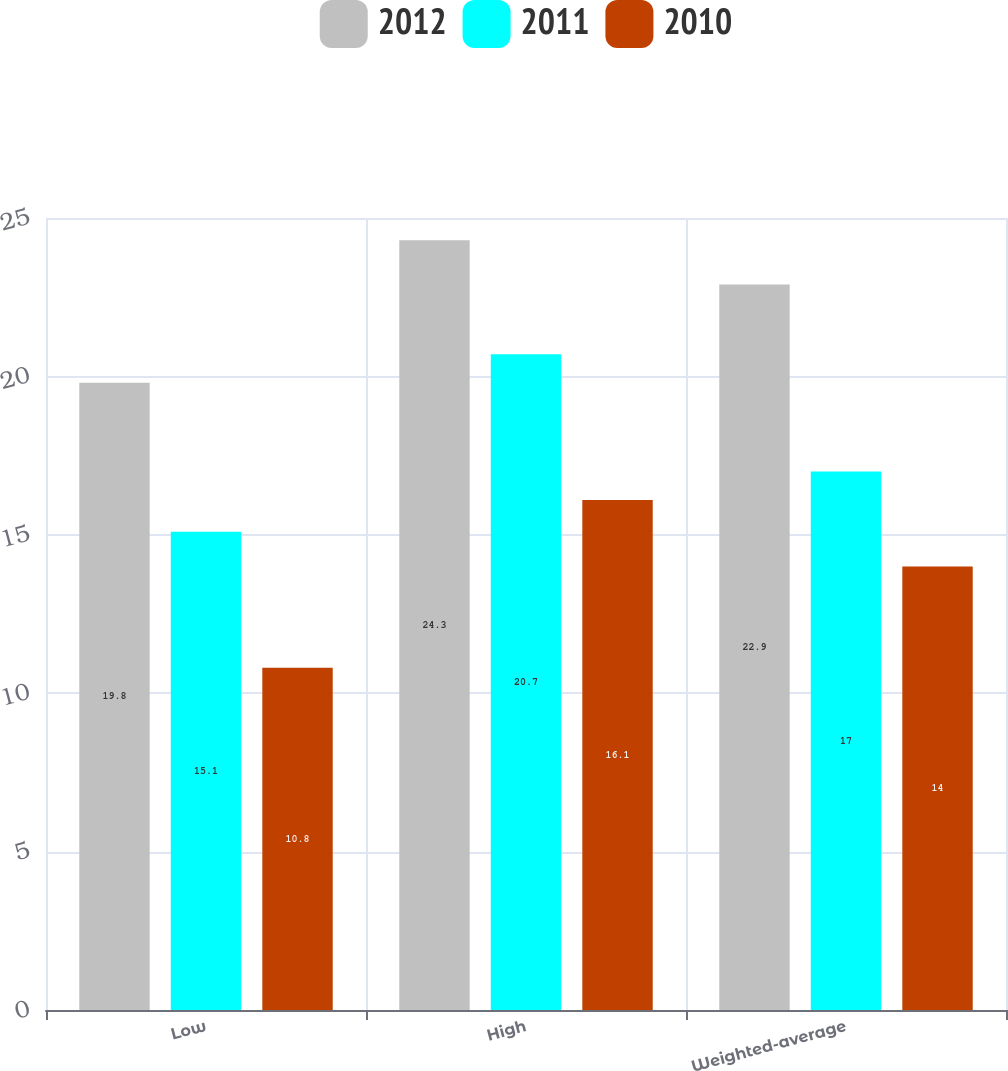Convert chart to OTSL. <chart><loc_0><loc_0><loc_500><loc_500><stacked_bar_chart><ecel><fcel>Low<fcel>High<fcel>Weighted-average<nl><fcel>2012<fcel>19.8<fcel>24.3<fcel>22.9<nl><fcel>2011<fcel>15.1<fcel>20.7<fcel>17<nl><fcel>2010<fcel>10.8<fcel>16.1<fcel>14<nl></chart> 